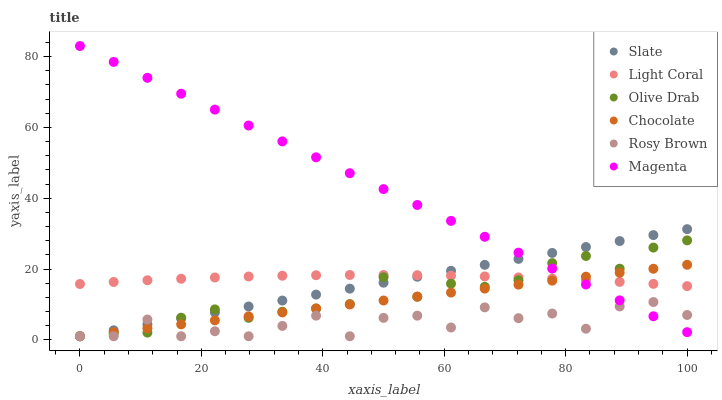Does Rosy Brown have the minimum area under the curve?
Answer yes or no. Yes. Does Magenta have the maximum area under the curve?
Answer yes or no. Yes. Does Chocolate have the minimum area under the curve?
Answer yes or no. No. Does Chocolate have the maximum area under the curve?
Answer yes or no. No. Is Chocolate the smoothest?
Answer yes or no. Yes. Is Rosy Brown the roughest?
Answer yes or no. Yes. Is Rosy Brown the smoothest?
Answer yes or no. No. Is Chocolate the roughest?
Answer yes or no. No. Does Slate have the lowest value?
Answer yes or no. Yes. Does Light Coral have the lowest value?
Answer yes or no. No. Does Magenta have the highest value?
Answer yes or no. Yes. Does Chocolate have the highest value?
Answer yes or no. No. Is Rosy Brown less than Light Coral?
Answer yes or no. Yes. Is Light Coral greater than Rosy Brown?
Answer yes or no. Yes. Does Olive Drab intersect Magenta?
Answer yes or no. Yes. Is Olive Drab less than Magenta?
Answer yes or no. No. Is Olive Drab greater than Magenta?
Answer yes or no. No. Does Rosy Brown intersect Light Coral?
Answer yes or no. No. 